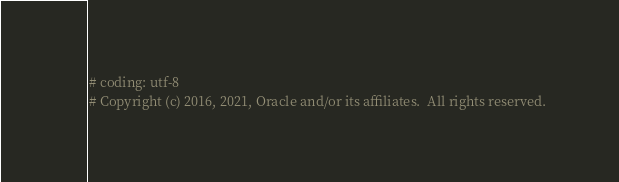Convert code to text. <code><loc_0><loc_0><loc_500><loc_500><_Python_># coding: utf-8
# Copyright (c) 2016, 2021, Oracle and/or its affiliates.  All rights reserved.</code> 